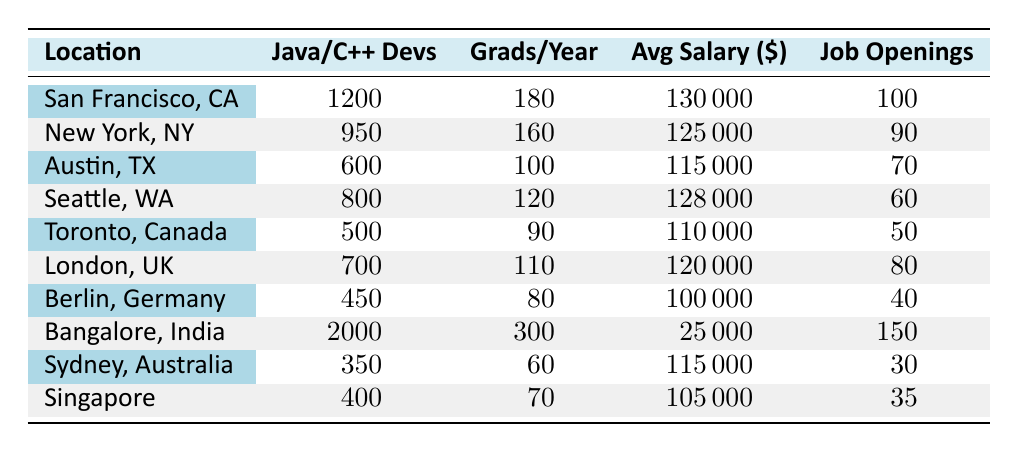What is the number of Java and C++ developers in San Francisco, CA? The table states that the number of Java and C++ developers in San Francisco, CA is specified directly.
Answer: 1200 What is the average salary of developers in Toronto, Canada? The average salary for developers in Toronto, Canada is provided directly in the table.
Answer: 110000 Which location has the highest number of job openings? By comparing the job openings across all locations listed in the table, Bangalore, India has the highest at 150.
Answer: Bangalore, India How many more university graduates per year does Bangalore have compared to Berlin? The number of university graduates per year in Bangalore is 300, and in Berlin, it is 80. Therefore, the difference is 300 - 80 = 220.
Answer: 220 What is the total number of Java and C++ developers across all locations? Summing up the number of developers from all locations, we have: 1200 + 950 + 600 + 800 + 500 + 700 + 450 + 2000 + 350 + 400 = 8750.
Answer: 8750 Is the average salary of developers in Sydney higher than that in Berlin? The average salary in Sydney is 115000 while in Berlin it is 100000. Since 115000 is more than 100000, the answer is yes.
Answer: Yes Which location has the least number of Java and C++ developers, and how many are there? The table shows that Berlin, Germany has the least number of Java and C++ developers with a count of 450.
Answer: Berlin, Germany; 450 What is the ratio of job openings to the number of developers in Austin, TX? In Austin, TX, the number of developers is 600 and the job openings are 70. The ratio is calculated as 600:70, which simplifies to approximately 8.57:1.
Answer: 8.57:1 In which two cities is the average salary above 120000? The table lists the average salaries and shows that only San Francisco, CA (130000) and New York, NY (125000) have salaries above 120000.
Answer: San Francisco, CA and New York, NY What is the median number of job openings from the listed locations? The job openings listed are: 100, 90, 70, 60, 50, 80, 40, 150, 30, 35. When sorted, they give us: 30, 35, 40, 50, 60, 70, 80, 90, 100, 150. The median of these (the average of the 5th and 6th values: 60 and 70) is (60 + 70) / 2 = 65.
Answer: 65 